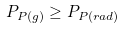<formula> <loc_0><loc_0><loc_500><loc_500>P _ { P ( g ) } \geq P _ { P ( r a d ) }</formula> 